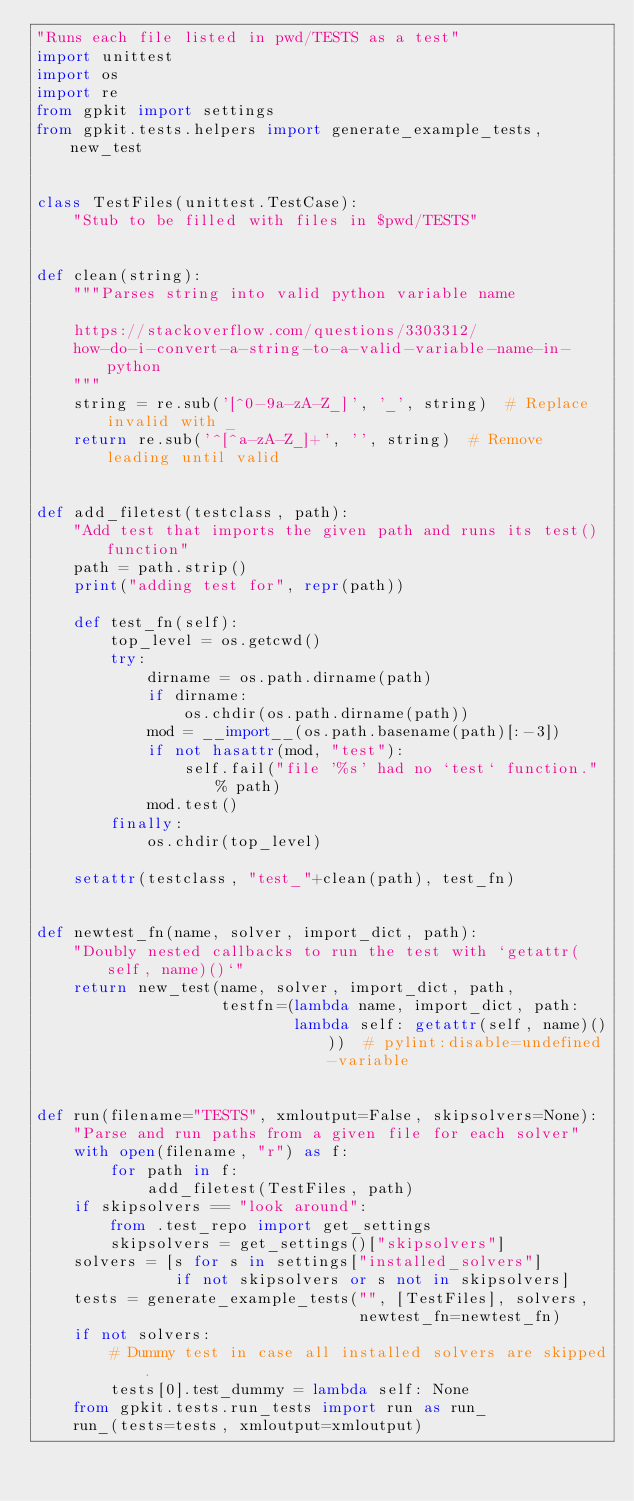Convert code to text. <code><loc_0><loc_0><loc_500><loc_500><_Python_>"Runs each file listed in pwd/TESTS as a test"
import unittest
import os
import re
from gpkit import settings
from gpkit.tests.helpers import generate_example_tests, new_test


class TestFiles(unittest.TestCase):
    "Stub to be filled with files in $pwd/TESTS"


def clean(string):
    """Parses string into valid python variable name

    https://stackoverflow.com/questions/3303312/
    how-do-i-convert-a-string-to-a-valid-variable-name-in-python
    """
    string = re.sub('[^0-9a-zA-Z_]', '_', string)  # Replace invalid with _
    return re.sub('^[^a-zA-Z_]+', '', string)  # Remove leading until valid


def add_filetest(testclass, path):
    "Add test that imports the given path and runs its test() function"
    path = path.strip()
    print("adding test for", repr(path))

    def test_fn(self):
        top_level = os.getcwd()
        try:
            dirname = os.path.dirname(path)
            if dirname:
                os.chdir(os.path.dirname(path))
            mod = __import__(os.path.basename(path)[:-3])
            if not hasattr(mod, "test"):
                self.fail("file '%s' had no `test` function." % path)
            mod.test()
        finally:
            os.chdir(top_level)

    setattr(testclass, "test_"+clean(path), test_fn)


def newtest_fn(name, solver, import_dict, path):
    "Doubly nested callbacks to run the test with `getattr(self, name)()`"
    return new_test(name, solver, import_dict, path,
                    testfn=(lambda name, import_dict, path:
                            lambda self: getattr(self, name)()))  # pylint:disable=undefined-variable


def run(filename="TESTS", xmloutput=False, skipsolvers=None):
    "Parse and run paths from a given file for each solver"
    with open(filename, "r") as f:
        for path in f:
            add_filetest(TestFiles, path)
    if skipsolvers == "look around":
        from .test_repo import get_settings
        skipsolvers = get_settings()["skipsolvers"]
    solvers = [s for s in settings["installed_solvers"]
               if not skipsolvers or s not in skipsolvers]
    tests = generate_example_tests("", [TestFiles], solvers,
                                   newtest_fn=newtest_fn)
    if not solvers:
        # Dummy test in case all installed solvers are skipped.
        tests[0].test_dummy = lambda self: None
    from gpkit.tests.run_tests import run as run_
    run_(tests=tests, xmloutput=xmloutput)
</code> 